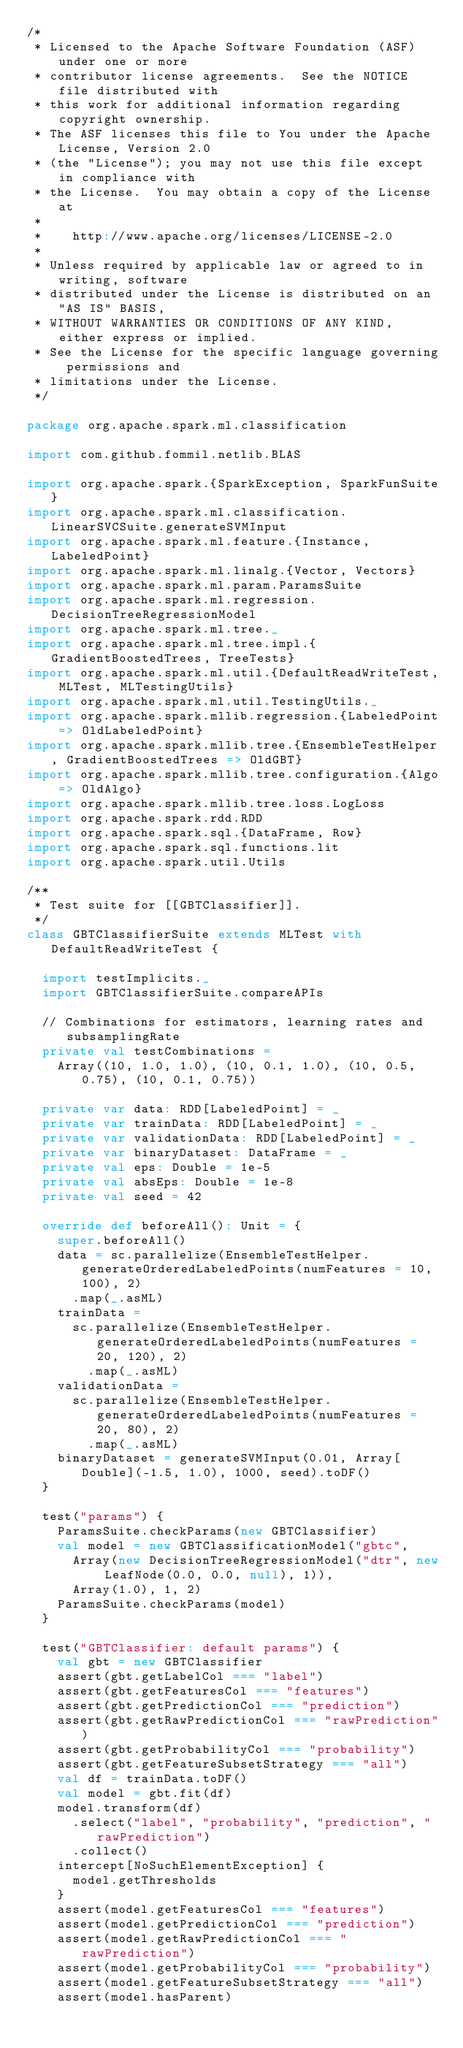<code> <loc_0><loc_0><loc_500><loc_500><_Scala_>/*
 * Licensed to the Apache Software Foundation (ASF) under one or more
 * contributor license agreements.  See the NOTICE file distributed with
 * this work for additional information regarding copyright ownership.
 * The ASF licenses this file to You under the Apache License, Version 2.0
 * (the "License"); you may not use this file except in compliance with
 * the License.  You may obtain a copy of the License at
 *
 *    http://www.apache.org/licenses/LICENSE-2.0
 *
 * Unless required by applicable law or agreed to in writing, software
 * distributed under the License is distributed on an "AS IS" BASIS,
 * WITHOUT WARRANTIES OR CONDITIONS OF ANY KIND, either express or implied.
 * See the License for the specific language governing permissions and
 * limitations under the License.
 */

package org.apache.spark.ml.classification

import com.github.fommil.netlib.BLAS

import org.apache.spark.{SparkException, SparkFunSuite}
import org.apache.spark.ml.classification.LinearSVCSuite.generateSVMInput
import org.apache.spark.ml.feature.{Instance, LabeledPoint}
import org.apache.spark.ml.linalg.{Vector, Vectors}
import org.apache.spark.ml.param.ParamsSuite
import org.apache.spark.ml.regression.DecisionTreeRegressionModel
import org.apache.spark.ml.tree._
import org.apache.spark.ml.tree.impl.{GradientBoostedTrees, TreeTests}
import org.apache.spark.ml.util.{DefaultReadWriteTest, MLTest, MLTestingUtils}
import org.apache.spark.ml.util.TestingUtils._
import org.apache.spark.mllib.regression.{LabeledPoint => OldLabeledPoint}
import org.apache.spark.mllib.tree.{EnsembleTestHelper, GradientBoostedTrees => OldGBT}
import org.apache.spark.mllib.tree.configuration.{Algo => OldAlgo}
import org.apache.spark.mllib.tree.loss.LogLoss
import org.apache.spark.rdd.RDD
import org.apache.spark.sql.{DataFrame, Row}
import org.apache.spark.sql.functions.lit
import org.apache.spark.util.Utils

/**
 * Test suite for [[GBTClassifier]].
 */
class GBTClassifierSuite extends MLTest with DefaultReadWriteTest {

  import testImplicits._
  import GBTClassifierSuite.compareAPIs

  // Combinations for estimators, learning rates and subsamplingRate
  private val testCombinations =
    Array((10, 1.0, 1.0), (10, 0.1, 1.0), (10, 0.5, 0.75), (10, 0.1, 0.75))

  private var data: RDD[LabeledPoint] = _
  private var trainData: RDD[LabeledPoint] = _
  private var validationData: RDD[LabeledPoint] = _
  private var binaryDataset: DataFrame = _
  private val eps: Double = 1e-5
  private val absEps: Double = 1e-8
  private val seed = 42

  override def beforeAll(): Unit = {
    super.beforeAll()
    data = sc.parallelize(EnsembleTestHelper.generateOrderedLabeledPoints(numFeatures = 10, 100), 2)
      .map(_.asML)
    trainData =
      sc.parallelize(EnsembleTestHelper.generateOrderedLabeledPoints(numFeatures = 20, 120), 2)
        .map(_.asML)
    validationData =
      sc.parallelize(EnsembleTestHelper.generateOrderedLabeledPoints(numFeatures = 20, 80), 2)
        .map(_.asML)
    binaryDataset = generateSVMInput(0.01, Array[Double](-1.5, 1.0), 1000, seed).toDF()
  }

  test("params") {
    ParamsSuite.checkParams(new GBTClassifier)
    val model = new GBTClassificationModel("gbtc",
      Array(new DecisionTreeRegressionModel("dtr", new LeafNode(0.0, 0.0, null), 1)),
      Array(1.0), 1, 2)
    ParamsSuite.checkParams(model)
  }

  test("GBTClassifier: default params") {
    val gbt = new GBTClassifier
    assert(gbt.getLabelCol === "label")
    assert(gbt.getFeaturesCol === "features")
    assert(gbt.getPredictionCol === "prediction")
    assert(gbt.getRawPredictionCol === "rawPrediction")
    assert(gbt.getProbabilityCol === "probability")
    assert(gbt.getFeatureSubsetStrategy === "all")
    val df = trainData.toDF()
    val model = gbt.fit(df)
    model.transform(df)
      .select("label", "probability", "prediction", "rawPrediction")
      .collect()
    intercept[NoSuchElementException] {
      model.getThresholds
    }
    assert(model.getFeaturesCol === "features")
    assert(model.getPredictionCol === "prediction")
    assert(model.getRawPredictionCol === "rawPrediction")
    assert(model.getProbabilityCol === "probability")
    assert(model.getFeatureSubsetStrategy === "all")
    assert(model.hasParent)
</code> 